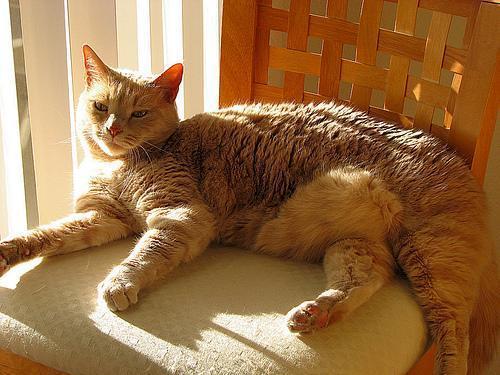How many people are walking on the sidewalk?
Give a very brief answer. 0. 